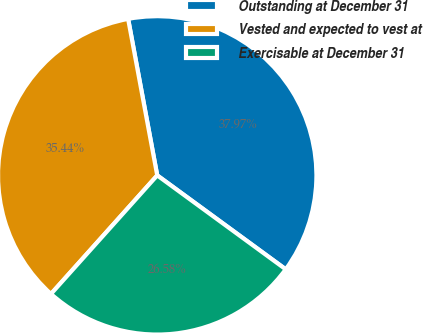Convert chart to OTSL. <chart><loc_0><loc_0><loc_500><loc_500><pie_chart><fcel>Outstanding at December 31<fcel>Vested and expected to vest at<fcel>Exercisable at December 31<nl><fcel>37.97%<fcel>35.44%<fcel>26.58%<nl></chart> 